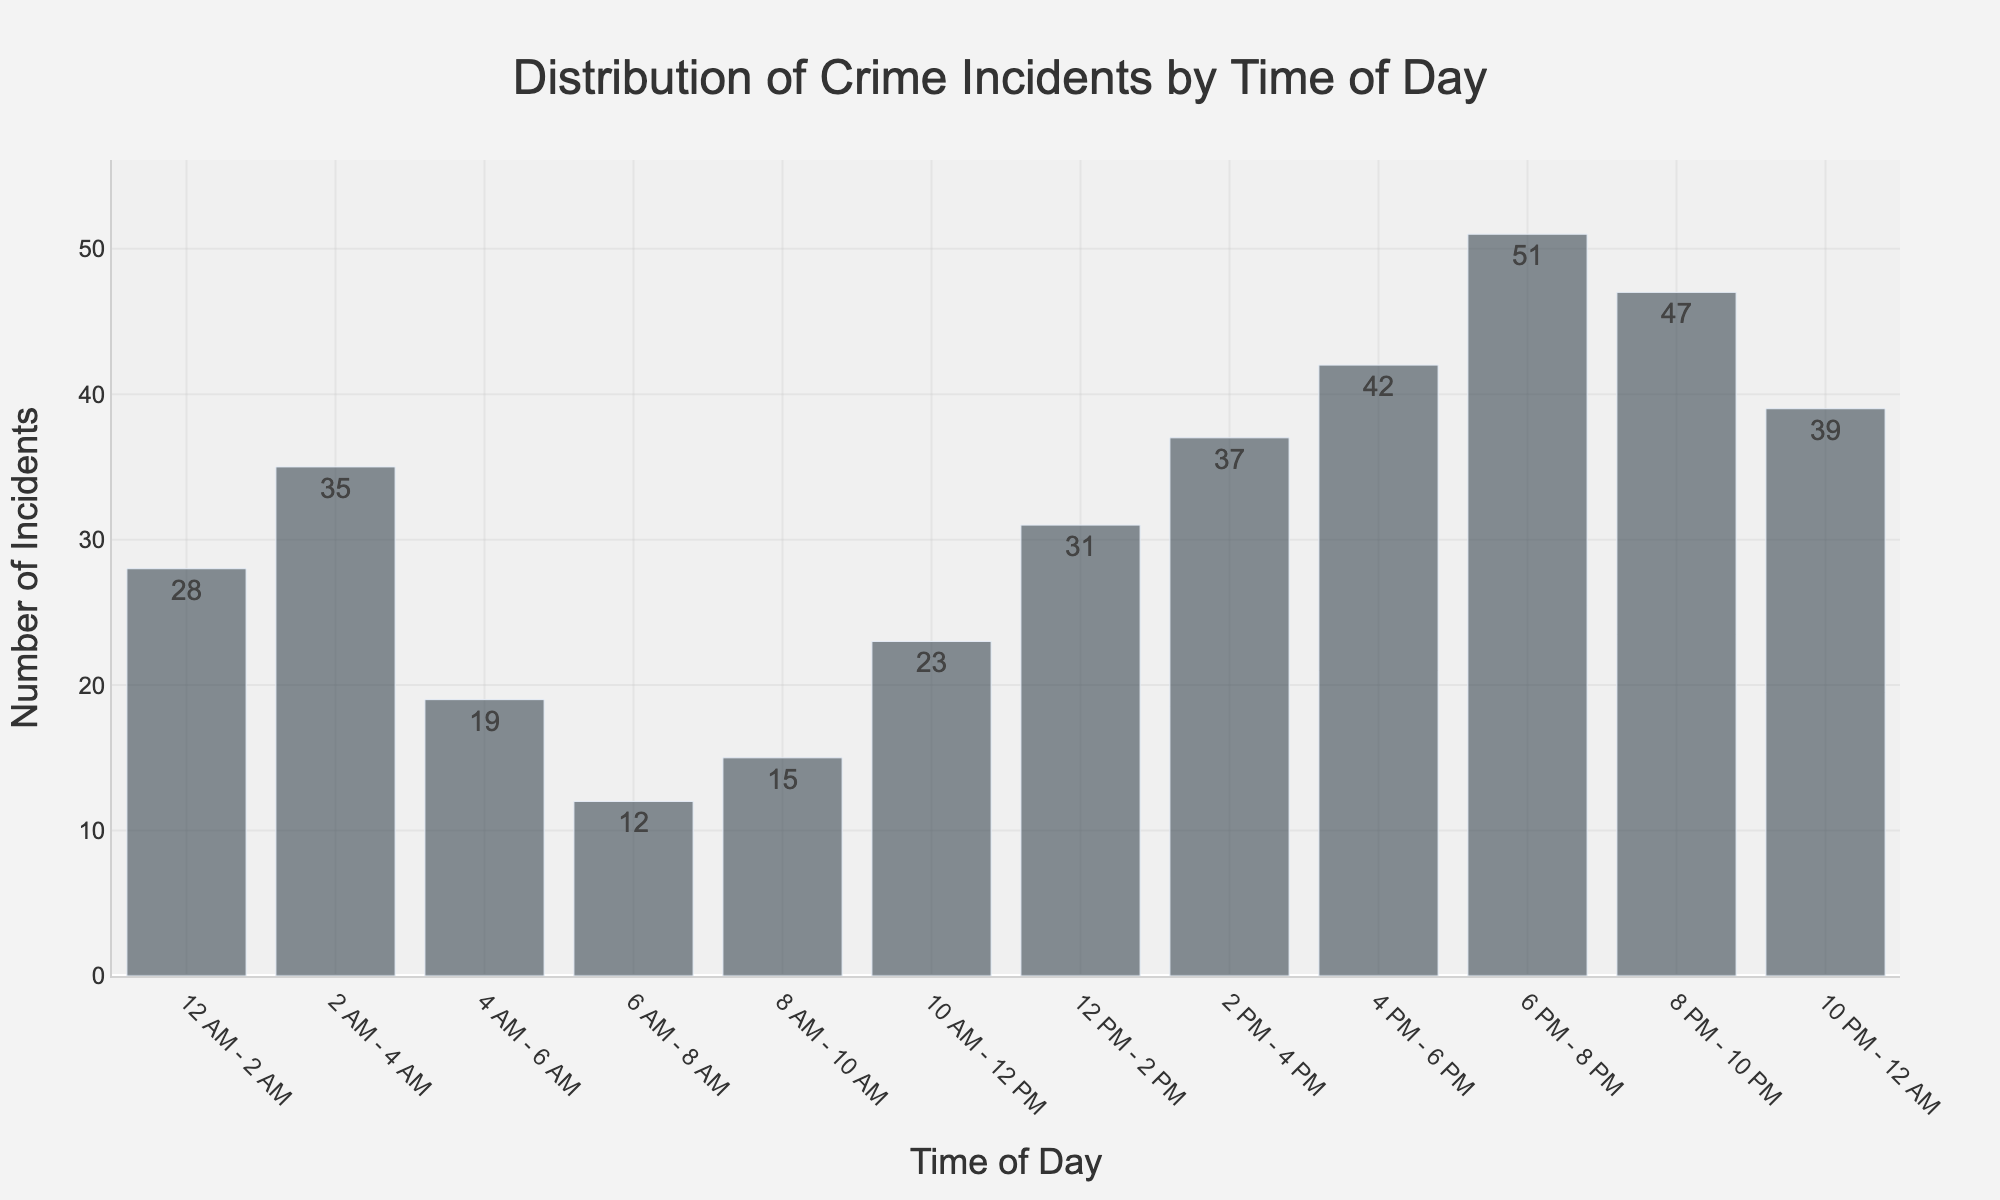How many total crime incidents occurred during the day (6 AM - 6 PM)? Sum the incidents from 6 AM - 8 AM (12), 8 AM - 10 AM (15), 10 AM - 12 PM (23), 12 PM - 2 PM (31), 2 PM - 4 PM (37), and 4 PM - 6 PM (42). 12 + 15 + 23 + 31 + 37 + 42 = 160.
Answer: 160 Which time period had the highest number of crime incidents? Identify the bar with the highest value. The 6 PM - 8 PM bar has the highest value, which is 51.
Answer: 6 PM - 8 PM What is the difference in the number of crime incidents between 6 PM - 8 PM and 2 PM - 4 PM? Subtract the number of incidents in the 2 PM - 4 PM period (37) from the 6 PM - 8 PM period (51). 51 - 37 = 14.
Answer: 14 What is the average number of crime incidents during the early morning hours (12 AM - 6 AM)? Calculate the average of the incidents from 12 AM - 2 AM (28), 2 AM - 4 AM (35), and 4 AM - 6 AM (19). (28 + 35 + 19) / 3 = 82 / 3 ≈ 27.3.
Answer: 27.3 During which time periods do crime incidents show a decreasing trend? Identify periods where incidents decrease from one time slot to the next. From 4 AM - 6 AM (19) to 6 AM - 8 AM (12), and from 8 PM - 10 PM (47) to 10 PM - 12 AM (39).
Answer: 4 AM - 8 AM, 8 PM - 12 AM What is the total number of crime incidents that occurred between 8 PM and 4 AM? Sum incidents from 8 PM - 10 PM (47), 10 PM - 12 AM (39), 12 AM - 2 AM (28), and 2 AM - 4 AM (35). 47 + 39 + 28 + 35 = 149.
Answer: 149 How does the number of incidents during 12 PM - 2 PM compare to 2 AM - 4 AM? Compare the values directly from the graph. 12 PM - 2 PM (31) is less than 2 AM - 4 AM (35).
Answer: Less Calculate the median number of crime incidents for all periods. List incidents (12, 15, 19, 23, 28, 31, 35, 37, 39, 42, 47, 51) and find the middle value. Since there are 12 periods, the median is the average of the 6th and 7th values: (31 + 35) / 2 = 33.
Answer: 33 Which time period had the second lowest number of crime incidents? Identify the bars and their heights. The lowest is 6 AM - 8 AM (12), and the second lowest is 8 AM - 10 AM (15).
Answer: 8 AM - 10 AM 